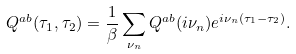<formula> <loc_0><loc_0><loc_500><loc_500>Q ^ { a b } ( \tau _ { 1 } , \tau _ { 2 } ) = \frac { 1 } { \beta } \sum _ { \nu _ { n } } Q ^ { a b } ( i \nu _ { n } ) e ^ { i \nu _ { n } ( \tau _ { 1 } - \tau _ { 2 } ) } .</formula> 